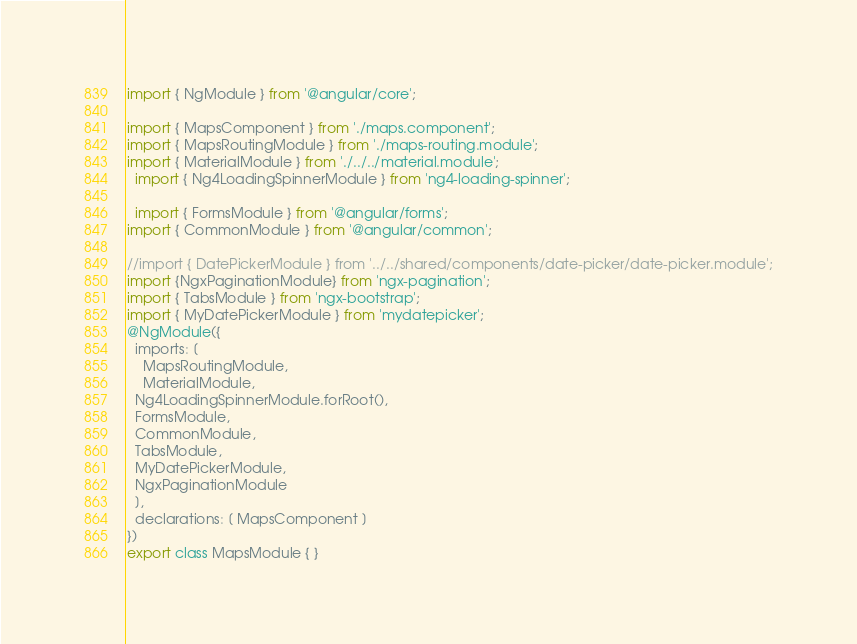Convert code to text. <code><loc_0><loc_0><loc_500><loc_500><_TypeScript_>import { NgModule } from '@angular/core';

import { MapsComponent } from './maps.component';
import { MapsRoutingModule } from './maps-routing.module';
import { MaterialModule } from './../../material.module';
  import { Ng4LoadingSpinnerModule } from 'ng4-loading-spinner';

  import { FormsModule } from '@angular/forms';
import { CommonModule } from '@angular/common';

//import { DatePickerModule } from '../../shared/components/date-picker/date-picker.module';
import {NgxPaginationModule} from 'ngx-pagination';
import { TabsModule } from 'ngx-bootstrap';
import { MyDatePickerModule } from 'mydatepicker';
@NgModule({
  imports: [
    MapsRoutingModule,
    MaterialModule,
  Ng4LoadingSpinnerModule.forRoot(),
  FormsModule,
  CommonModule,
  TabsModule,
  MyDatePickerModule,
  NgxPaginationModule
  ],
  declarations: [ MapsComponent ]
})
export class MapsModule { }
</code> 